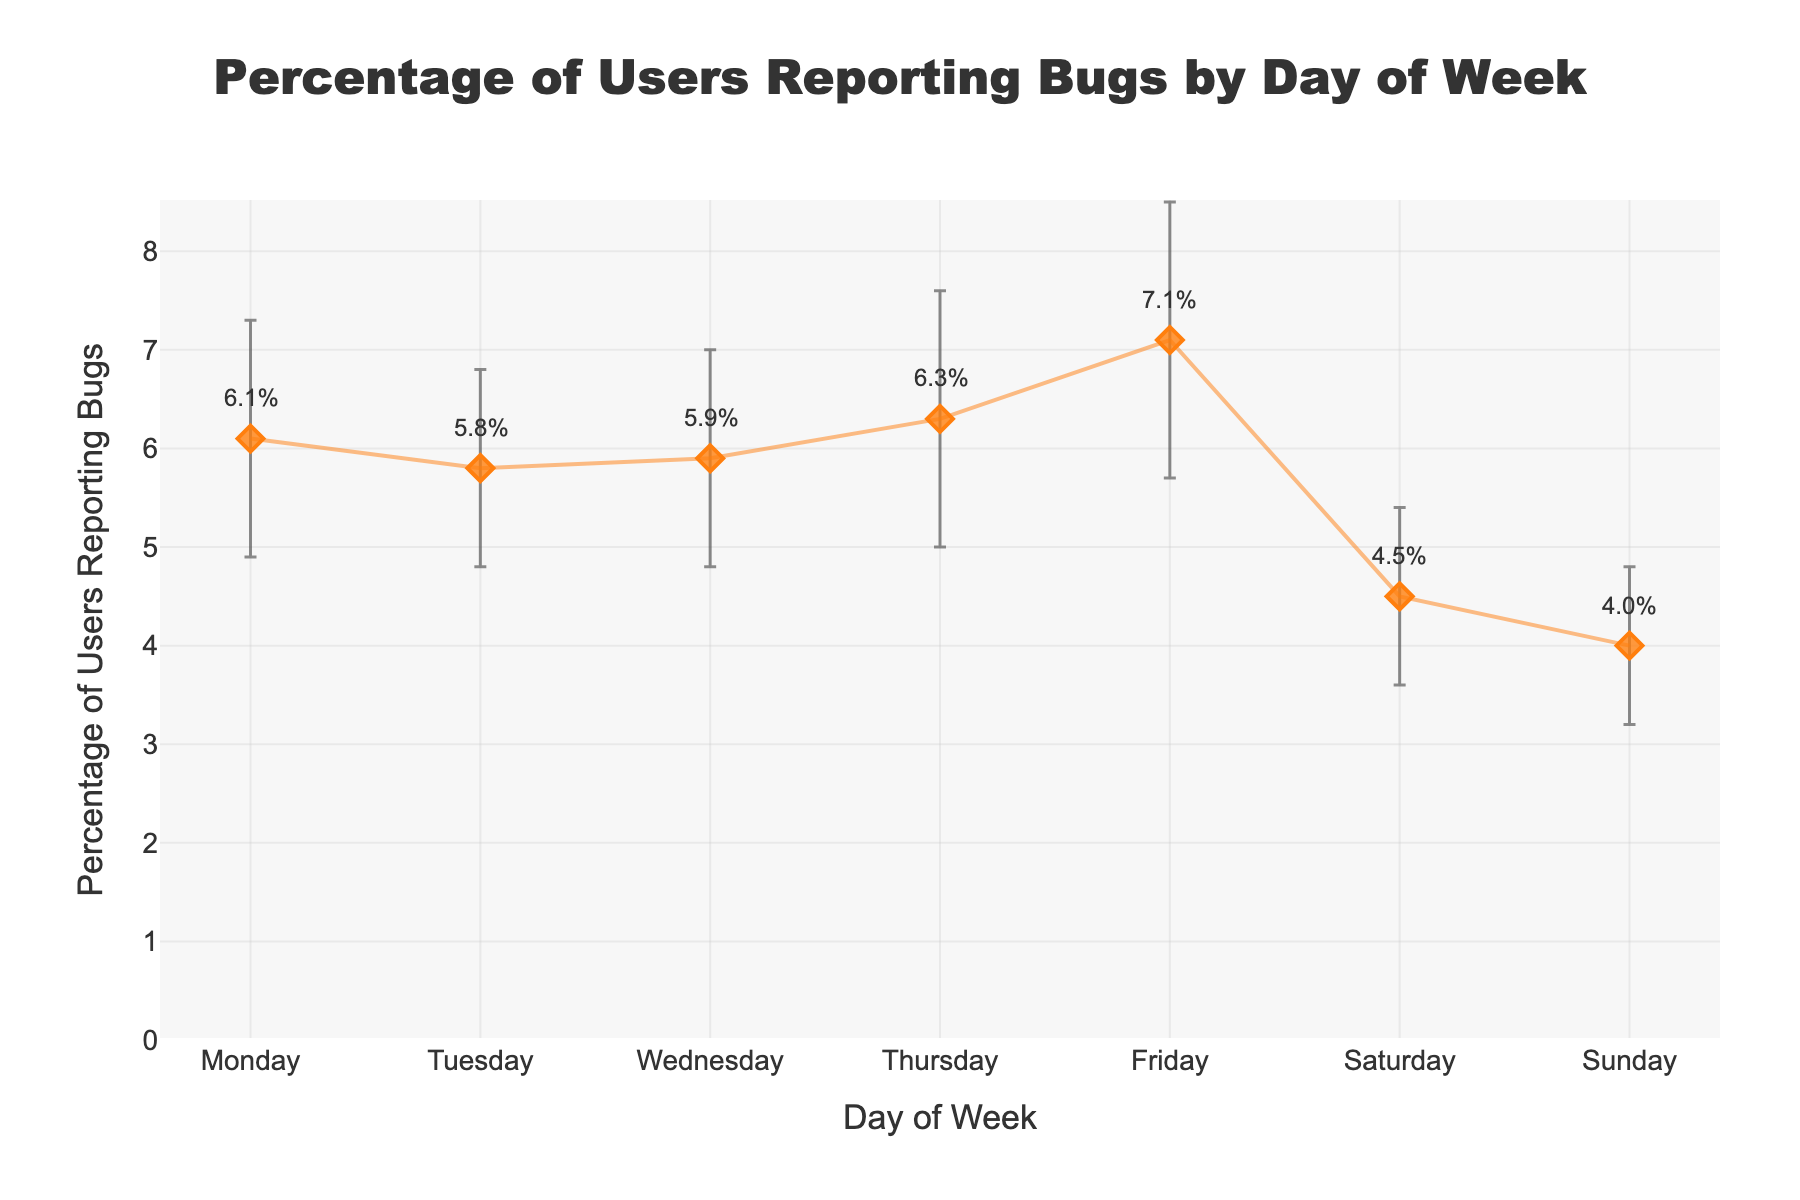What is the title of the plot? The title is the large text at the top center of the plot. Reading it directly provides the information.
Answer: Percentage of Users Reporting Bugs by Day of Week What does the x-axis represent? The x-axis labels are directly below the horizontal line at the bottom of the plot. Reading these labels identifies their representation.
Answer: Day of Week On which day is the mean percentage of users reporting bugs the highest? By examining the plot, we compare the heights of the points for each day. The highest point indicates the day with the highest mean percentage.
Answer: Friday What is the percentage of users reporting bugs on Wednesday? There is a data label near the Wednesday point on the plot. Reading the annotation provides the percentage.
Answer: 5.9% How much does the mean percentage of users reporting bugs change from Saturday to Monday? We subtract the percentage of Saturday from Monday by interpreting their y-values on the plot: 6.1 (Monday) - 4.5 (Saturday).
Answer: 1.6% Which day has the smallest variation in bug reports? The error bars represent variation. The shortest error bar indicates the smallest standard deviation.
Answer: Sunday How does the percentage of bug reports on Tuesday compare to Thursday? By comparing the y-values for Tuesday and Thursday on the plot, Tuesday's point is lower than Thursday's.
Answer: Tuesday is lower than Thursday What is the range of the mean percentage of bug reports throughout the week? Identify the maximum and minimum percentages on the plot. The highest value is 7.1% (Friday), and the lowest is 4.0% (Sunday). We subtract the minimum from the maximum: 7.1 - 4.0.
Answer: 3.1% Which days have a mean percentage of bug reports above 6%? We look across the plot to find days where the percentage is above the 6% line. The days with points above this line are Monday, Thursday, and Friday.
Answer: Monday, Thursday, Friday How does the mean percentage of bug reports on Wednesday compare to the average percentage of the entire week? First, calculate the average for the week: (6.1 + 5.8 + 5.9 + 6.3 + 7.1 + 4.5 + 4.0)/7 = 5.671. Then, compare Wednesday's 5.9% to this average.
Answer: 5.9% is above the weekly average of 5.671% 